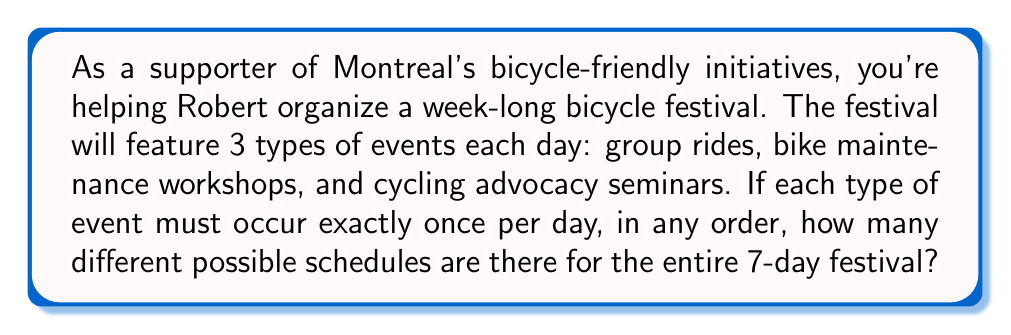Show me your answer to this math problem. Let's approach this step-by-step:

1) For each day, we need to arrange 3 events in a specific order. This is a permutation of 3 items, which can be done in $3! = 3 \times 2 \times 1 = 6$ ways.

2) We need to make this arrangement for each of the 7 days of the festival. Since the arrangement of each day is independent of the others, we can use the multiplication principle.

3) The total number of possible schedules is therefore:

   $$(3!)^7 = 6^7$$

4) Let's calculate this:
   $$6^7 = 6 \times 6 \times 6 \times 6 \times 6 \times 6 \times 6 = 279,936$$

Therefore, there are 279,936 different possible schedules for the entire 7-day festival.
Answer: 279,936 